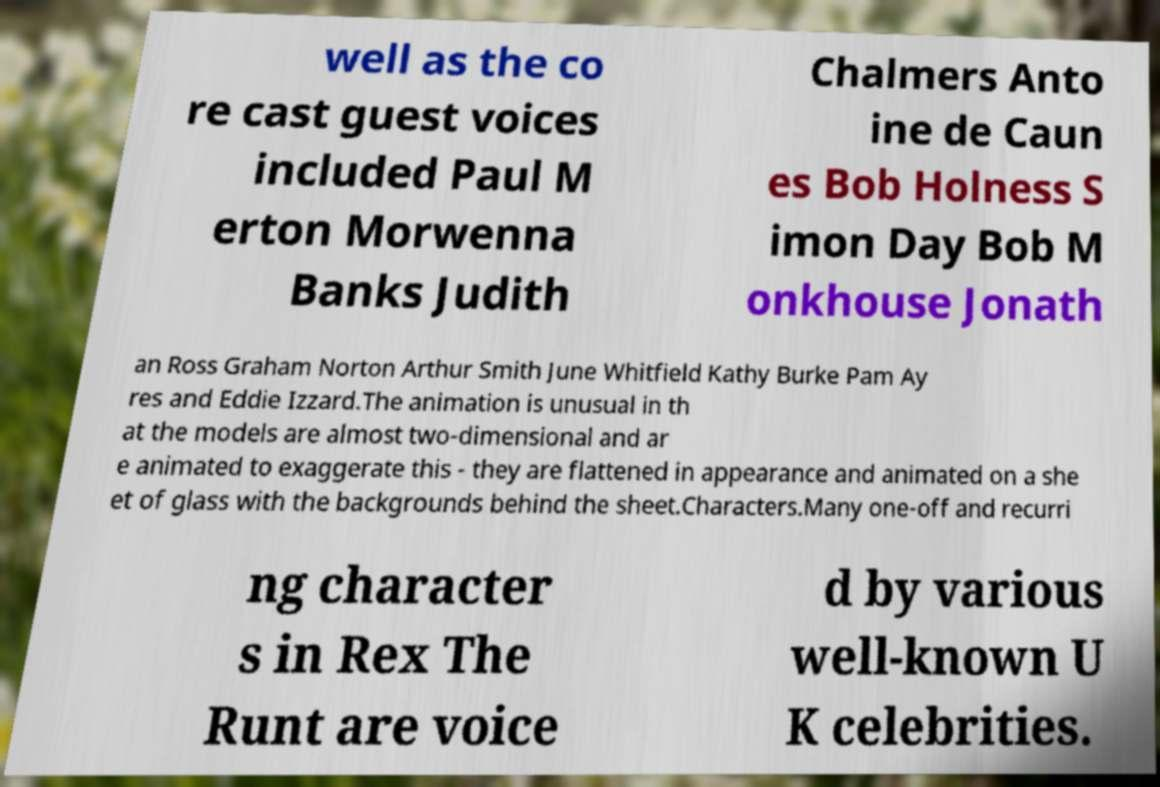There's text embedded in this image that I need extracted. Can you transcribe it verbatim? well as the co re cast guest voices included Paul M erton Morwenna Banks Judith Chalmers Anto ine de Caun es Bob Holness S imon Day Bob M onkhouse Jonath an Ross Graham Norton Arthur Smith June Whitfield Kathy Burke Pam Ay res and Eddie Izzard.The animation is unusual in th at the models are almost two-dimensional and ar e animated to exaggerate this - they are flattened in appearance and animated on a she et of glass with the backgrounds behind the sheet.Characters.Many one-off and recurri ng character s in Rex The Runt are voice d by various well-known U K celebrities. 